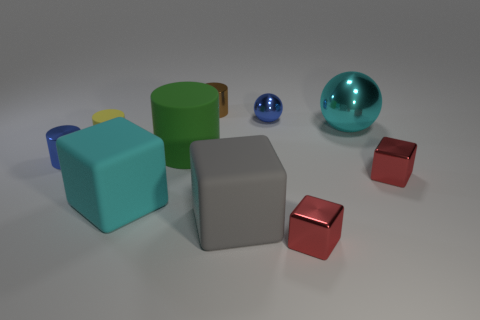How many cylinders are gray objects or tiny objects?
Offer a terse response. 3. There is another cylinder that is the same material as the green cylinder; what is its size?
Provide a succinct answer. Small. There is a metal cube to the right of the large cyan shiny sphere; is it the same size as the blue shiny thing behind the blue cylinder?
Give a very brief answer. Yes. What number of objects are small brown metal objects or large red cubes?
Provide a short and direct response. 1. What shape is the yellow rubber object?
Offer a very short reply. Cylinder. What is the size of the other shiny object that is the same shape as the large cyan metal object?
Make the answer very short. Small. Are there any other things that are made of the same material as the cyan ball?
Offer a terse response. Yes. There is a cylinder behind the small yellow thing in front of the blue shiny sphere; what size is it?
Offer a very short reply. Small. Are there an equal number of small cylinders in front of the large rubber cylinder and big cyan matte cubes?
Provide a succinct answer. Yes. How many other things are there of the same color as the large metallic object?
Make the answer very short. 1. 